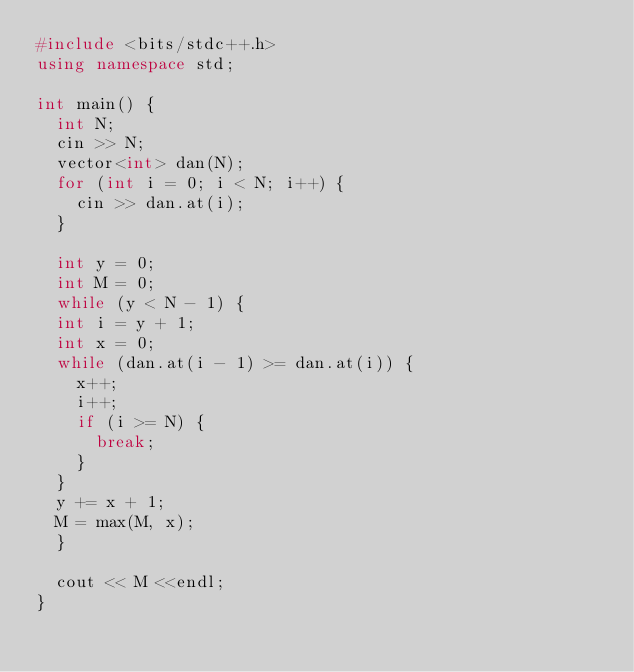Convert code to text. <code><loc_0><loc_0><loc_500><loc_500><_C++_>#include <bits/stdc++.h>
using namespace std;

int main() {
  int N;
  cin >> N;
  vector<int> dan(N);
  for (int i = 0; i < N; i++) {
    cin >> dan.at(i);
  }
  
  int y = 0;
  int M = 0;
  while (y < N - 1) {
  int i = y + 1;
  int x = 0;
  while (dan.at(i - 1) >= dan.at(i)) {
    x++;
    i++;
    if (i >= N) {
      break;
    }
  }
  y += x + 1;
  M = max(M, x);
  }

  cout << M <<endl;
}</code> 